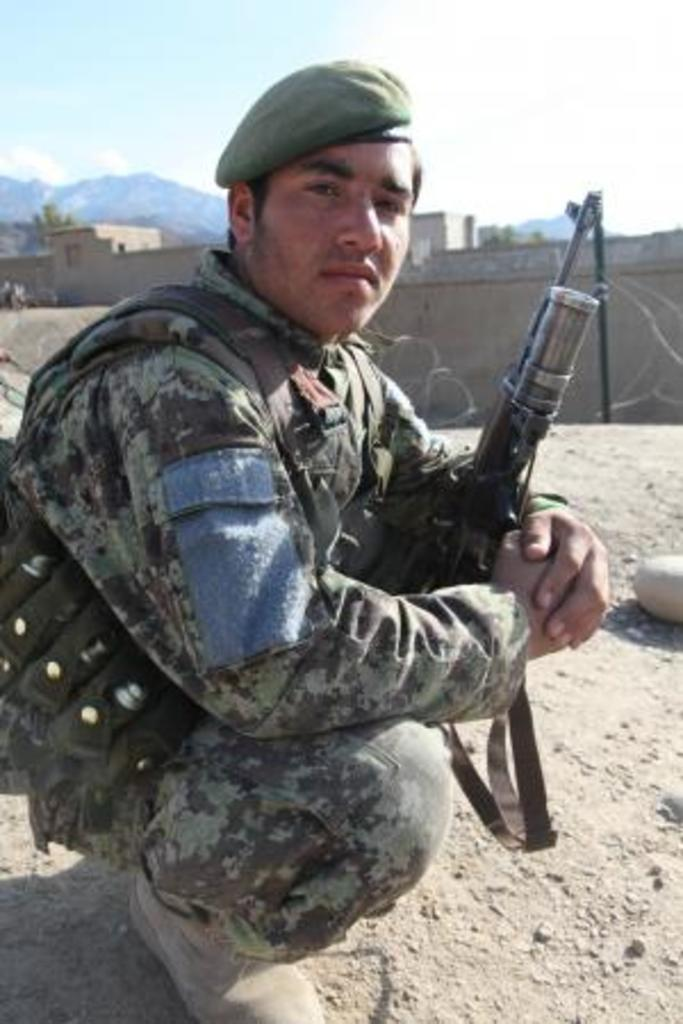What is the man in the image doing? The man is sitting in the image. What is the man holding in the image? The man is holding a weapon. What can be seen behind the man in the image? There is a fencing behind the man. What type of natural environment is visible in the image? There are trees and hills visible in the image. What is visible at the top of the image? Clouds and the sky are visible at the top of the image. What type of shoe is the man wearing in the image? There is no information about the man's shoes in the image, so we cannot determine what type of shoe he is wearing. What is the man using the wrench for in the image? There is no wrench present in the image, so we cannot determine what the man might be using it for. 